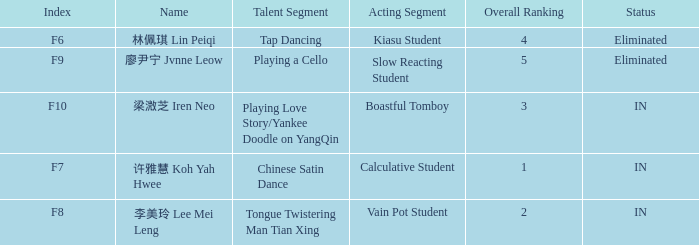For the event with index f9, what's the talent segment? Playing a Cello. 